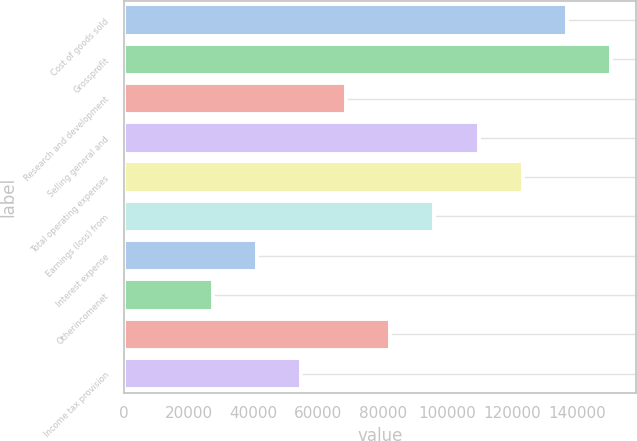<chart> <loc_0><loc_0><loc_500><loc_500><bar_chart><fcel>Cost of goods sold<fcel>Grossprofit<fcel>Research and development<fcel>Selling general and<fcel>Total operating expenses<fcel>Earnings (loss) from<fcel>Interest expense<fcel>Otherincomenet<fcel>Unnamed: 8<fcel>Income tax provision<nl><fcel>137020<fcel>150722<fcel>68511.2<fcel>109616<fcel>123318<fcel>95914.7<fcel>41107.6<fcel>27405.9<fcel>82212.9<fcel>54809.4<nl></chart> 